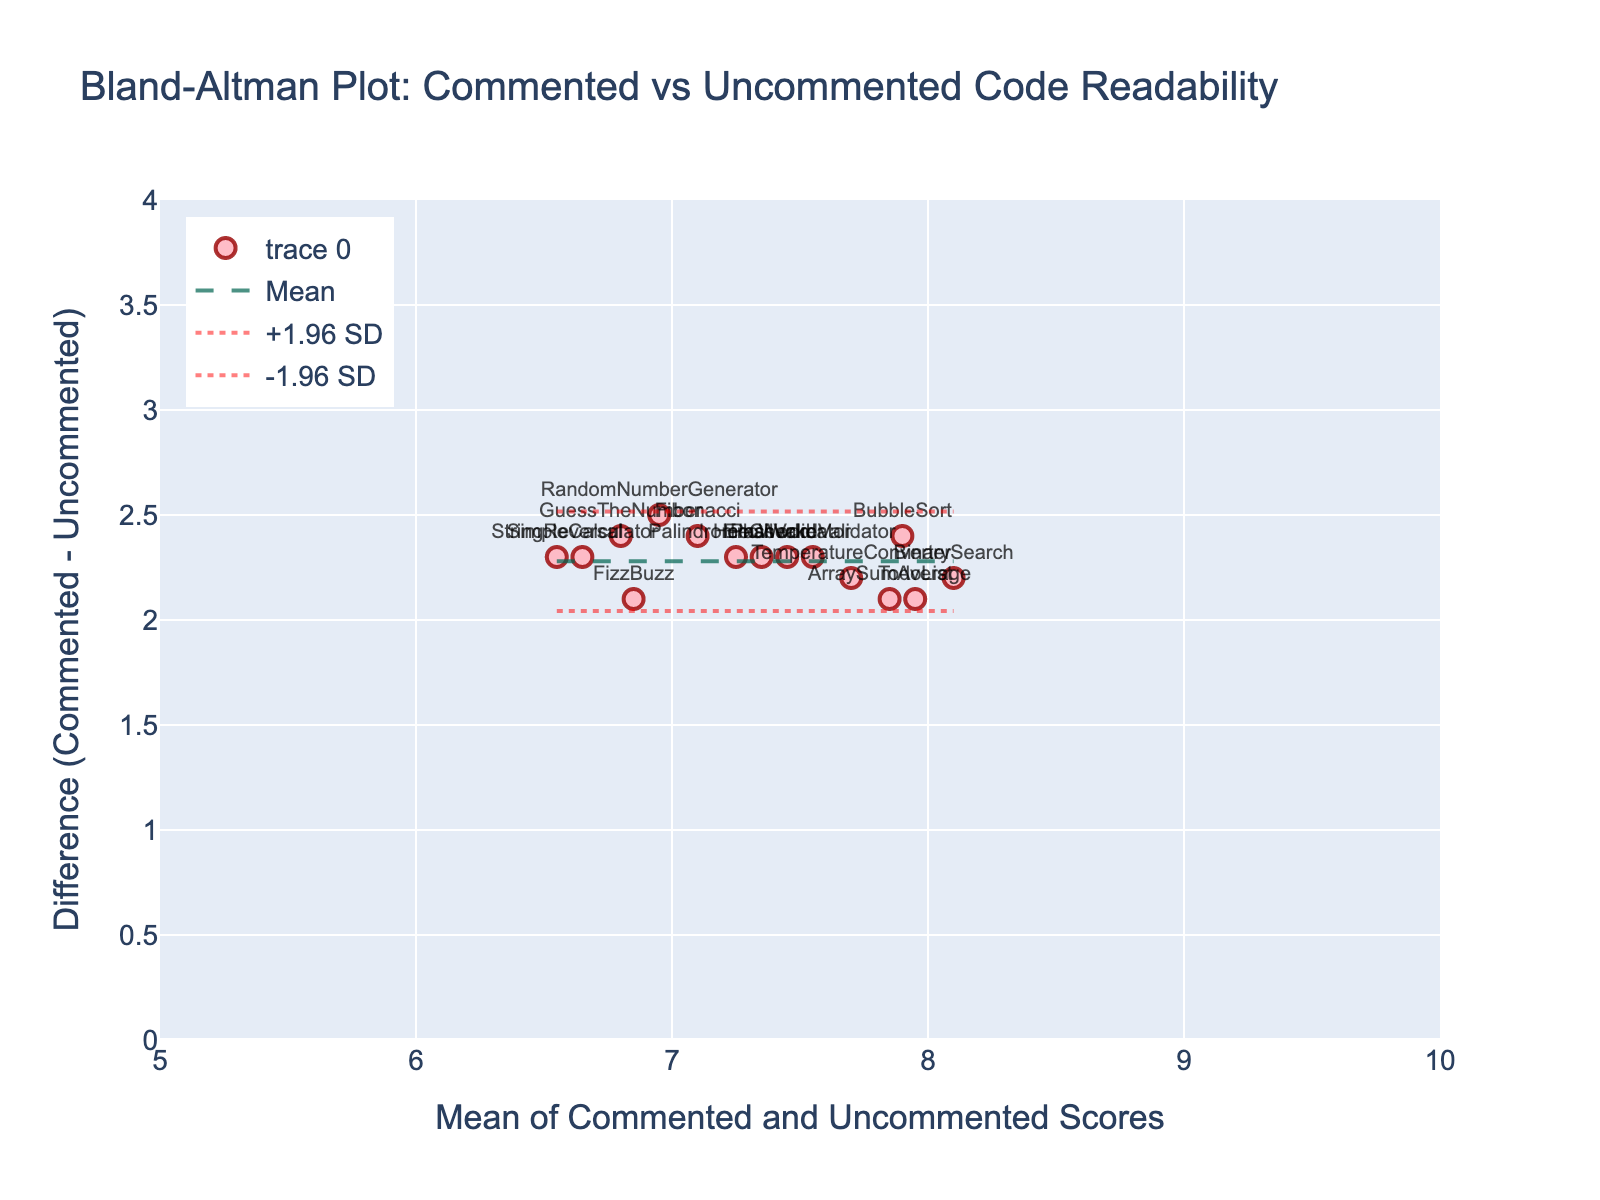What's the title of the figure? The title of the figure is generally found at the top and is clearly displayed to indicate the subject of the graph. In this case, it reads "Bland-Altman Plot: Commented vs Uncommented Code Readability".
Answer: Bland-Altman Plot: Commented vs Uncommented Code Readability What do the labels on the x and y axes represent? Axis labels provide information on what the axes measure. The x-axis label is 'Mean of Commented and Uncommented Scores,' representing the average readability score for both commented and uncommented code snippets. The y-axis label is 'Difference (Commented - Uncommented),' indicating the difference in readability scores between commented and uncommented code.
Answer: Mean of Commented and Uncommented Scores; Difference (Commented - Uncommented) How many data points are plotted in this figure? Each data point corresponds to a different code snippet. From the visual scatter plot, there are markers for each snippet. There are 15 markers on the plot, corresponding to the 15 different code snippets in the dataset.
Answer: 15 What's the approximate range of the y-axis in the plot? The range of the y-axis can be estimated by looking at the highest and lowest points the axis covers. From the provided configuration, it spans from 0 to 4.
Answer: 0 to 4 What's the mean difference in readability scores between commented and uncommented code? The mean difference is usually represented by a line on the plot. In this figure, it's the dashed line running horizontally across the plot. The exact mathematical values are computed but are visible on this line. This line is at approximately 2.5.
Answer: 2.5 Which code snippet has the highest mean readability score, and what is it? Look for the highest point on the x-axis, as the mean scores are plotted there. The `BinarySearch` snippet appears closest to the high end. Cross-referencing this with the mean scores calculation would confirm it. Its mean score is the highest at around 8.1.
Answer: BinarySearch, 8.1 What are the upper and lower limits of agreement, and how are they depicted? The limits of agreement are typically lines above and below the mean difference line. They represent ±1.96 times the standard deviation of the differences. The plot uses these dotted lines to mark these limits, which appear around 4.5 and 0.5, respectively.
Answer: Upper: 4.5, Lower: 0.5 Which code snippet has the largest difference in readability scores, and what is that difference? The largest difference would be the highest or lowest point on the y-axis. The snippet `BubbleSort` seems to have the highest positive difference, close to the upper limit of around 3.4.
Answer: BubbleSort, 3.4 How does the readability of the `SimpleCalculator` snippet compare between commented and uncommented code? Find the `SimpleCalculator` point on the scatter plot and observe its y-value for the difference. The `SimpleCalculator` snippet's difference is around 2.3, indicating commented code readability is 2.3 units higher than uncommented.
Answer: 2.3 units higher 